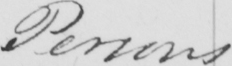What does this handwritten line say? Persons 